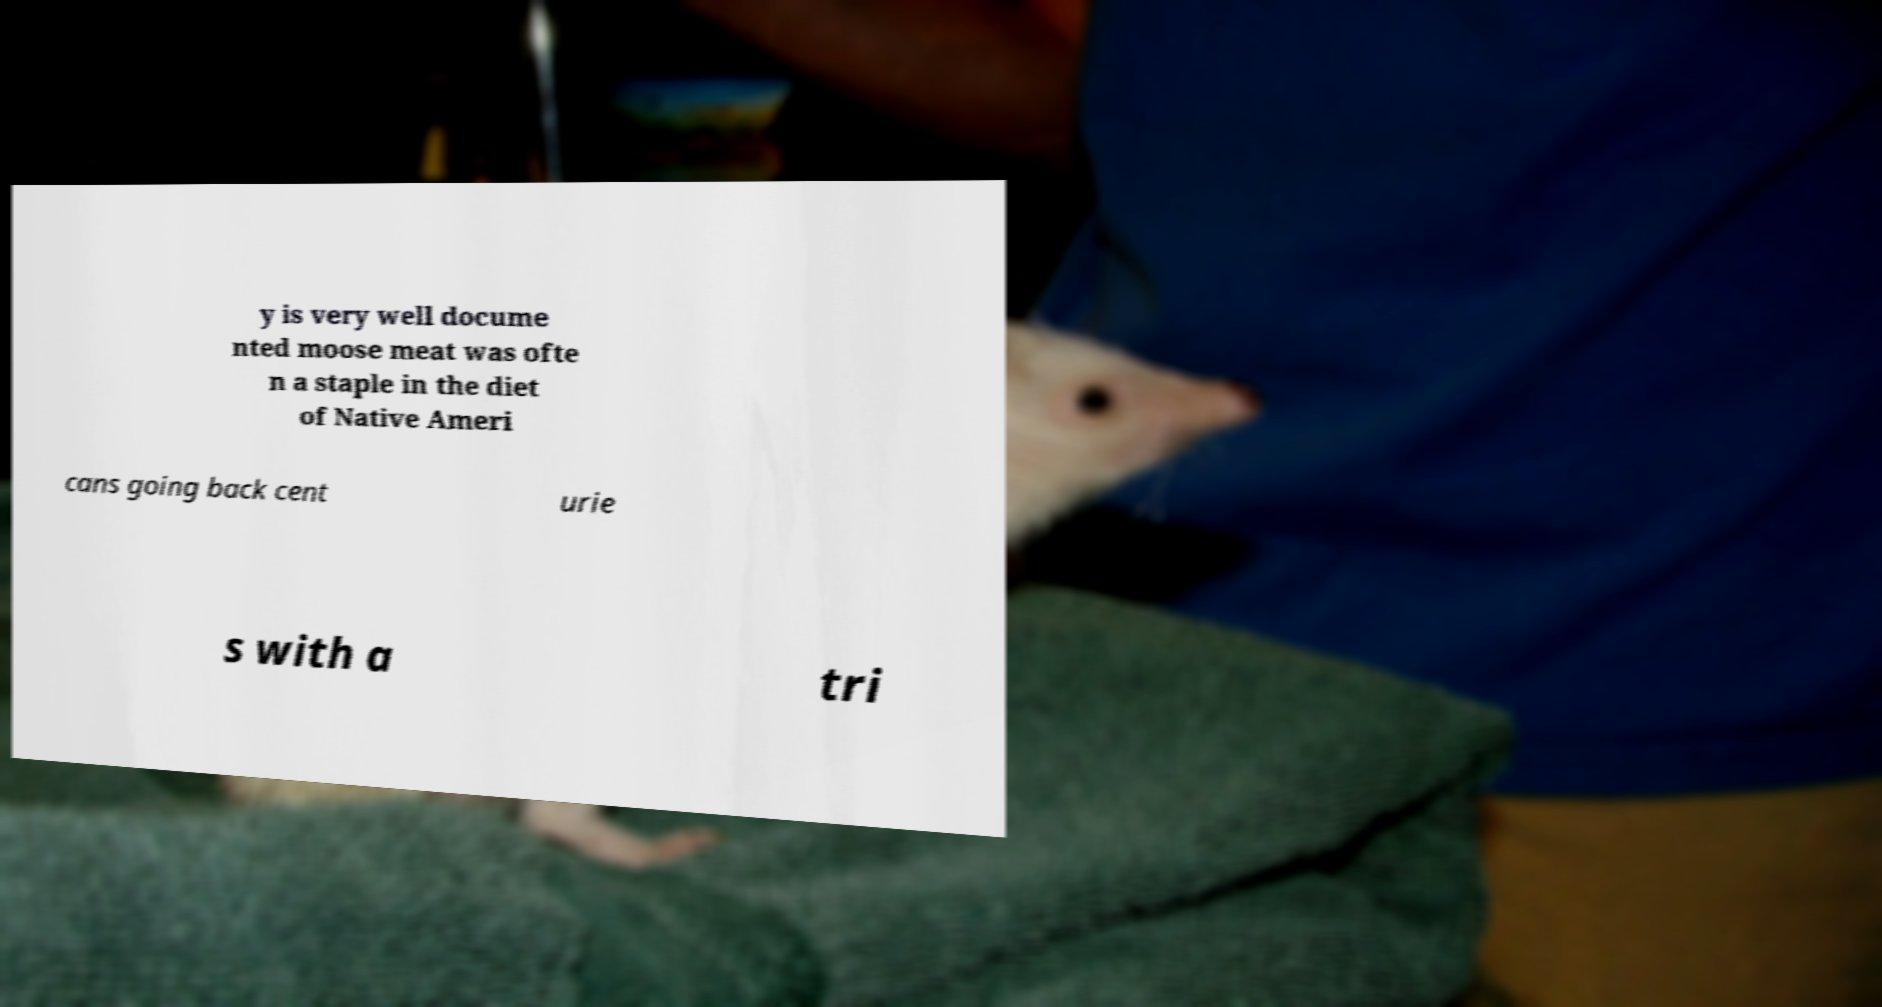I need the written content from this picture converted into text. Can you do that? y is very well docume nted moose meat was ofte n a staple in the diet of Native Ameri cans going back cent urie s with a tri 